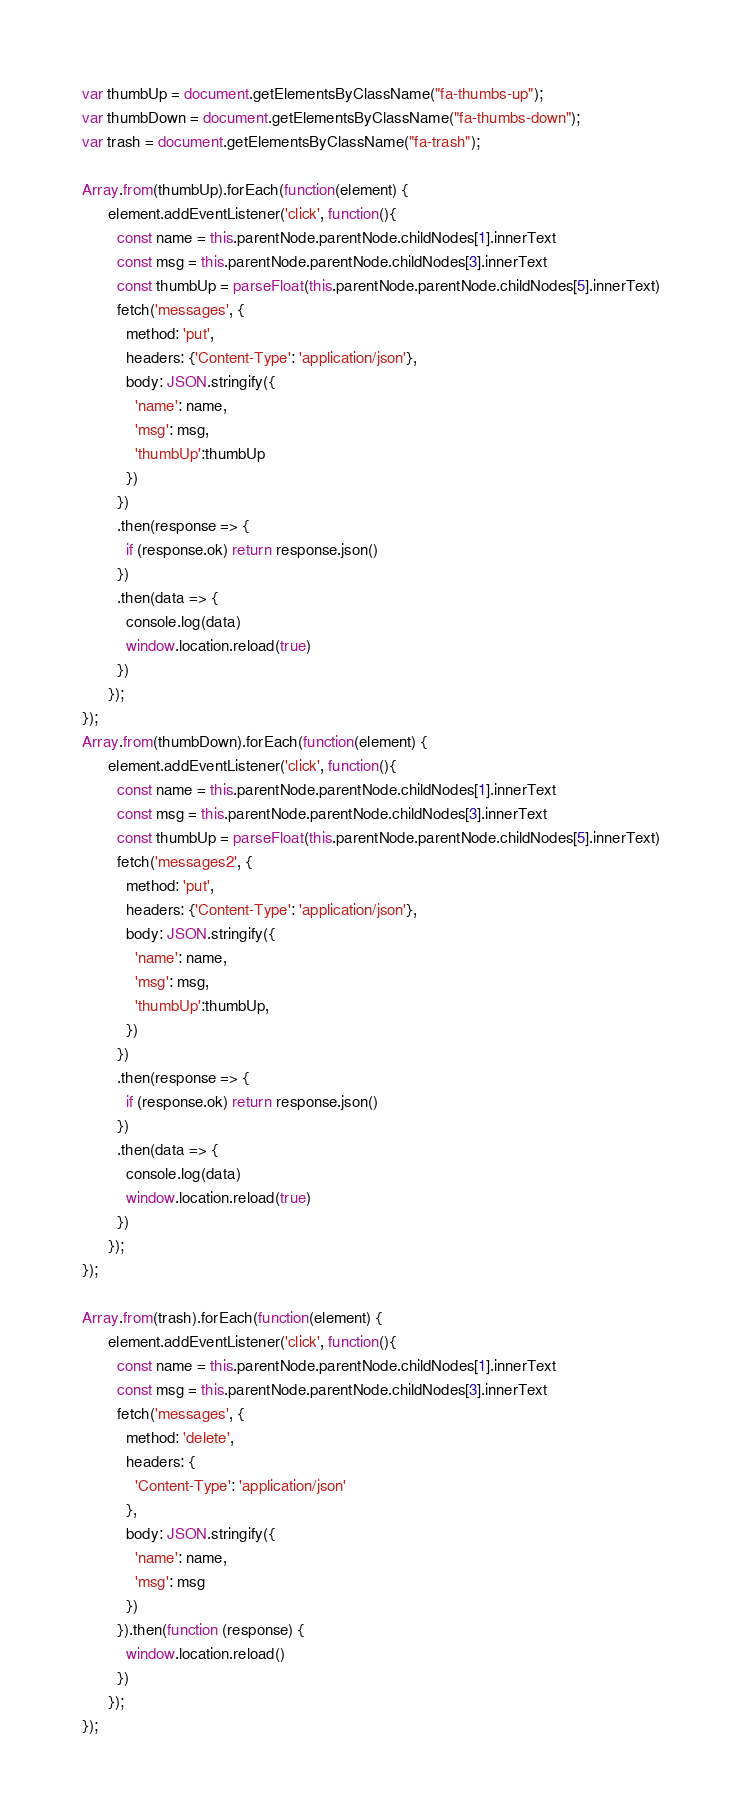Convert code to text. <code><loc_0><loc_0><loc_500><loc_500><_JavaScript_>var thumbUp = document.getElementsByClassName("fa-thumbs-up");
var thumbDown = document.getElementsByClassName("fa-thumbs-down");
var trash = document.getElementsByClassName("fa-trash");

Array.from(thumbUp).forEach(function(element) {
      element.addEventListener('click', function(){
        const name = this.parentNode.parentNode.childNodes[1].innerText
        const msg = this.parentNode.parentNode.childNodes[3].innerText
        const thumbUp = parseFloat(this.parentNode.parentNode.childNodes[5].innerText)
        fetch('messages', {
          method: 'put',
          headers: {'Content-Type': 'application/json'},
          body: JSON.stringify({
            'name': name,
            'msg': msg,
            'thumbUp':thumbUp
          })
        })
        .then(response => {
          if (response.ok) return response.json()
        })
        .then(data => {
          console.log(data)
          window.location.reload(true)
        })
      });
});
Array.from(thumbDown).forEach(function(element) {
      element.addEventListener('click', function(){
        const name = this.parentNode.parentNode.childNodes[1].innerText
        const msg = this.parentNode.parentNode.childNodes[3].innerText
        const thumbUp = parseFloat(this.parentNode.parentNode.childNodes[5].innerText)
        fetch('messages2', {
          method: 'put',
          headers: {'Content-Type': 'application/json'},
          body: JSON.stringify({
            'name': name,
            'msg': msg,
            'thumbUp':thumbUp,
          })
        })
        .then(response => {
          if (response.ok) return response.json()
        })
        .then(data => {
          console.log(data)
          window.location.reload(true)
        })
      });
});

Array.from(trash).forEach(function(element) {
      element.addEventListener('click', function(){
        const name = this.parentNode.parentNode.childNodes[1].innerText
        const msg = this.parentNode.parentNode.childNodes[3].innerText
        fetch('messages', {
          method: 'delete',
          headers: {
            'Content-Type': 'application/json'
          },
          body: JSON.stringify({
            'name': name,
            'msg': msg
          })
        }).then(function (response) {
          window.location.reload()
        })
      });
});
</code> 